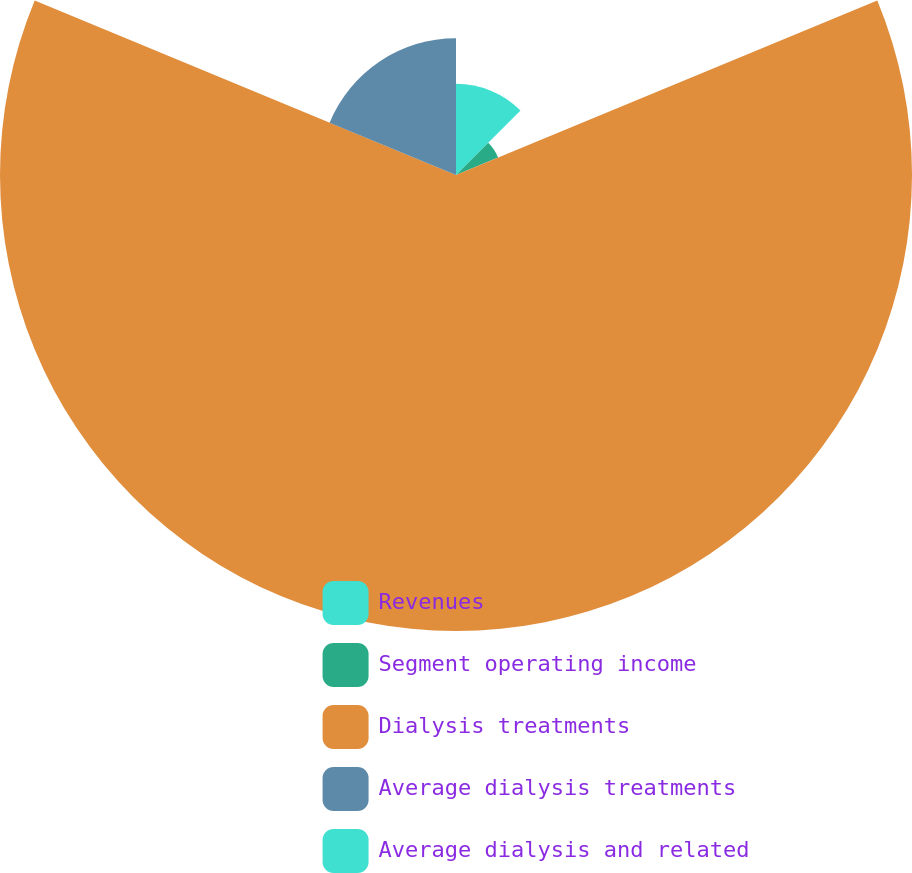Convert chart. <chart><loc_0><loc_0><loc_500><loc_500><pie_chart><fcel>Revenues<fcel>Segment operating income<fcel>Dialysis treatments<fcel>Average dialysis treatments<fcel>Average dialysis and related<nl><fcel>12.5%<fcel>6.25%<fcel>62.5%<fcel>18.75%<fcel>0.0%<nl></chart> 